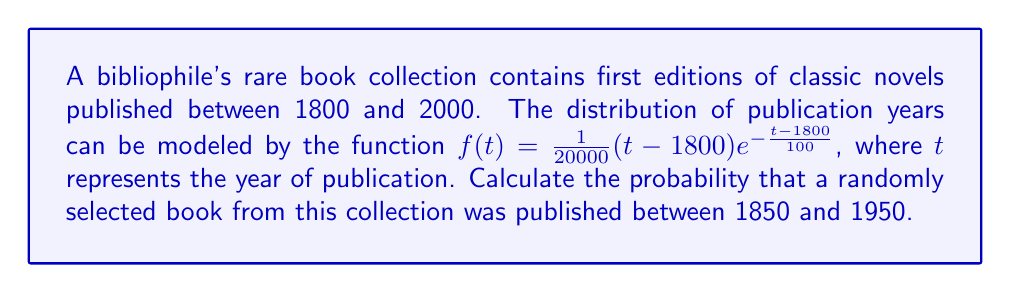What is the answer to this math problem? To solve this problem, we need to use definite integrals to find the probability. The steps are as follows:

1) The probability density function is given by:
   $$f(t) = \frac{1}{20000}(t-1800)e^{-\frac{t-1800}{100}}$$

2) To find the probability that a book was published between 1850 and 1950, we need to integrate this function from 1850 to 1950:

   $$P(1850 \leq t \leq 1950) = \int_{1850}^{1950} \frac{1}{20000}(t-1800)e^{-\frac{t-1800}{100}} dt$$

3) This integral is complex, so we'll use the substitution method:
   Let $u = t - 1800$, then $du = dt$ and when $t = 1850$, $u = 50$; when $t = 1950$, $u = 150$

4) The integral becomes:
   $$\int_{50}^{150} \frac{1}{20000}ue^{-\frac{u}{100}} du$$

5) This is of the form $\int x e^{ax} dx$, which has the solution $\frac{e^{ax}}{a^2}(-ax-1)$ plus a constant

6) Applying this to our integral:
   $$\left[-\frac{e^{-\frac{u}{100}}}{100}(u+100)\right]_{50}^{150}$$

7) Evaluating at the limits:
   $$\left[-\frac{e^{-\frac{150}{100}}}{100}(150+100)\right] - \left[-\frac{e^{-\frac{50}{100}}}{100}(50+100)\right]$$

8) Simplifying:
   $$-2.5e^{-1.5} + 1.5e^{-0.5} \approx 0.5724$$

Therefore, the probability is approximately 0.5724 or 57.24%.
Answer: The probability that a randomly selected book from the collection was published between 1850 and 1950 is approximately 0.5724 or 57.24%. 